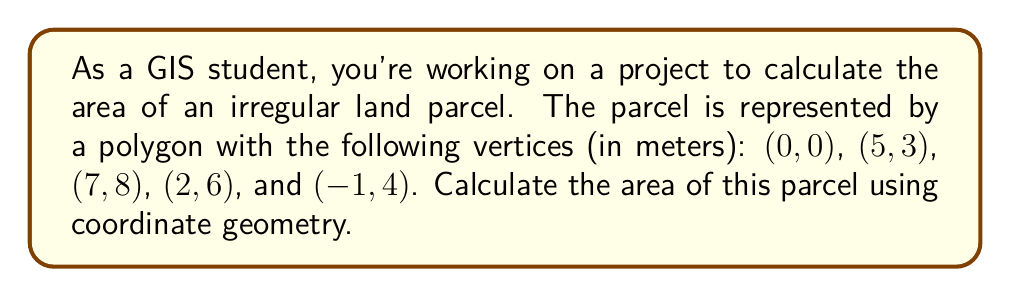Can you answer this question? To calculate the area of an irregular polygon using coordinate geometry, we can use the Shoelace formula (also known as the surveyor's formula). The steps are as follows:

1. List the coordinates in order (either clockwise or counterclockwise), repeating the first coordinate at the end:
   $(x_1, y_1), (x_2, y_2), ..., (x_n, y_n), (x_1, y_1)$

   In this case: (0,0), (5,3), (7,8), (2,6), (-1,4), (0,0)

2. Apply the Shoelace formula:
   $$A = \frac{1}{2}|(x_1y_2 + x_2y_3 + ... + x_ny_1) - (y_1x_2 + y_2x_3 + ... + y_nx_1)|$$

3. Substitute the values:
   $$A = \frac{1}{2}|(0 \cdot 3 + 5 \cdot 8 + 7 \cdot 6 + 2 \cdot 4 + (-1) \cdot 0) - (0 \cdot 5 + 3 \cdot 7 + 8 \cdot 2 + 6 \cdot (-1) + 4 \cdot 0)|$$

4. Calculate:
   $$A = \frac{1}{2}|(0 + 40 + 42 + 8 + 0) - (0 + 21 + 16 - 6 + 0)|$$
   $$A = \frac{1}{2}|90 - 31|$$
   $$A = \frac{1}{2} \cdot 59$$
   $$A = 29.5$$

Therefore, the area of the irregular polygon is 29.5 square meters.
Answer: 29.5 m² 